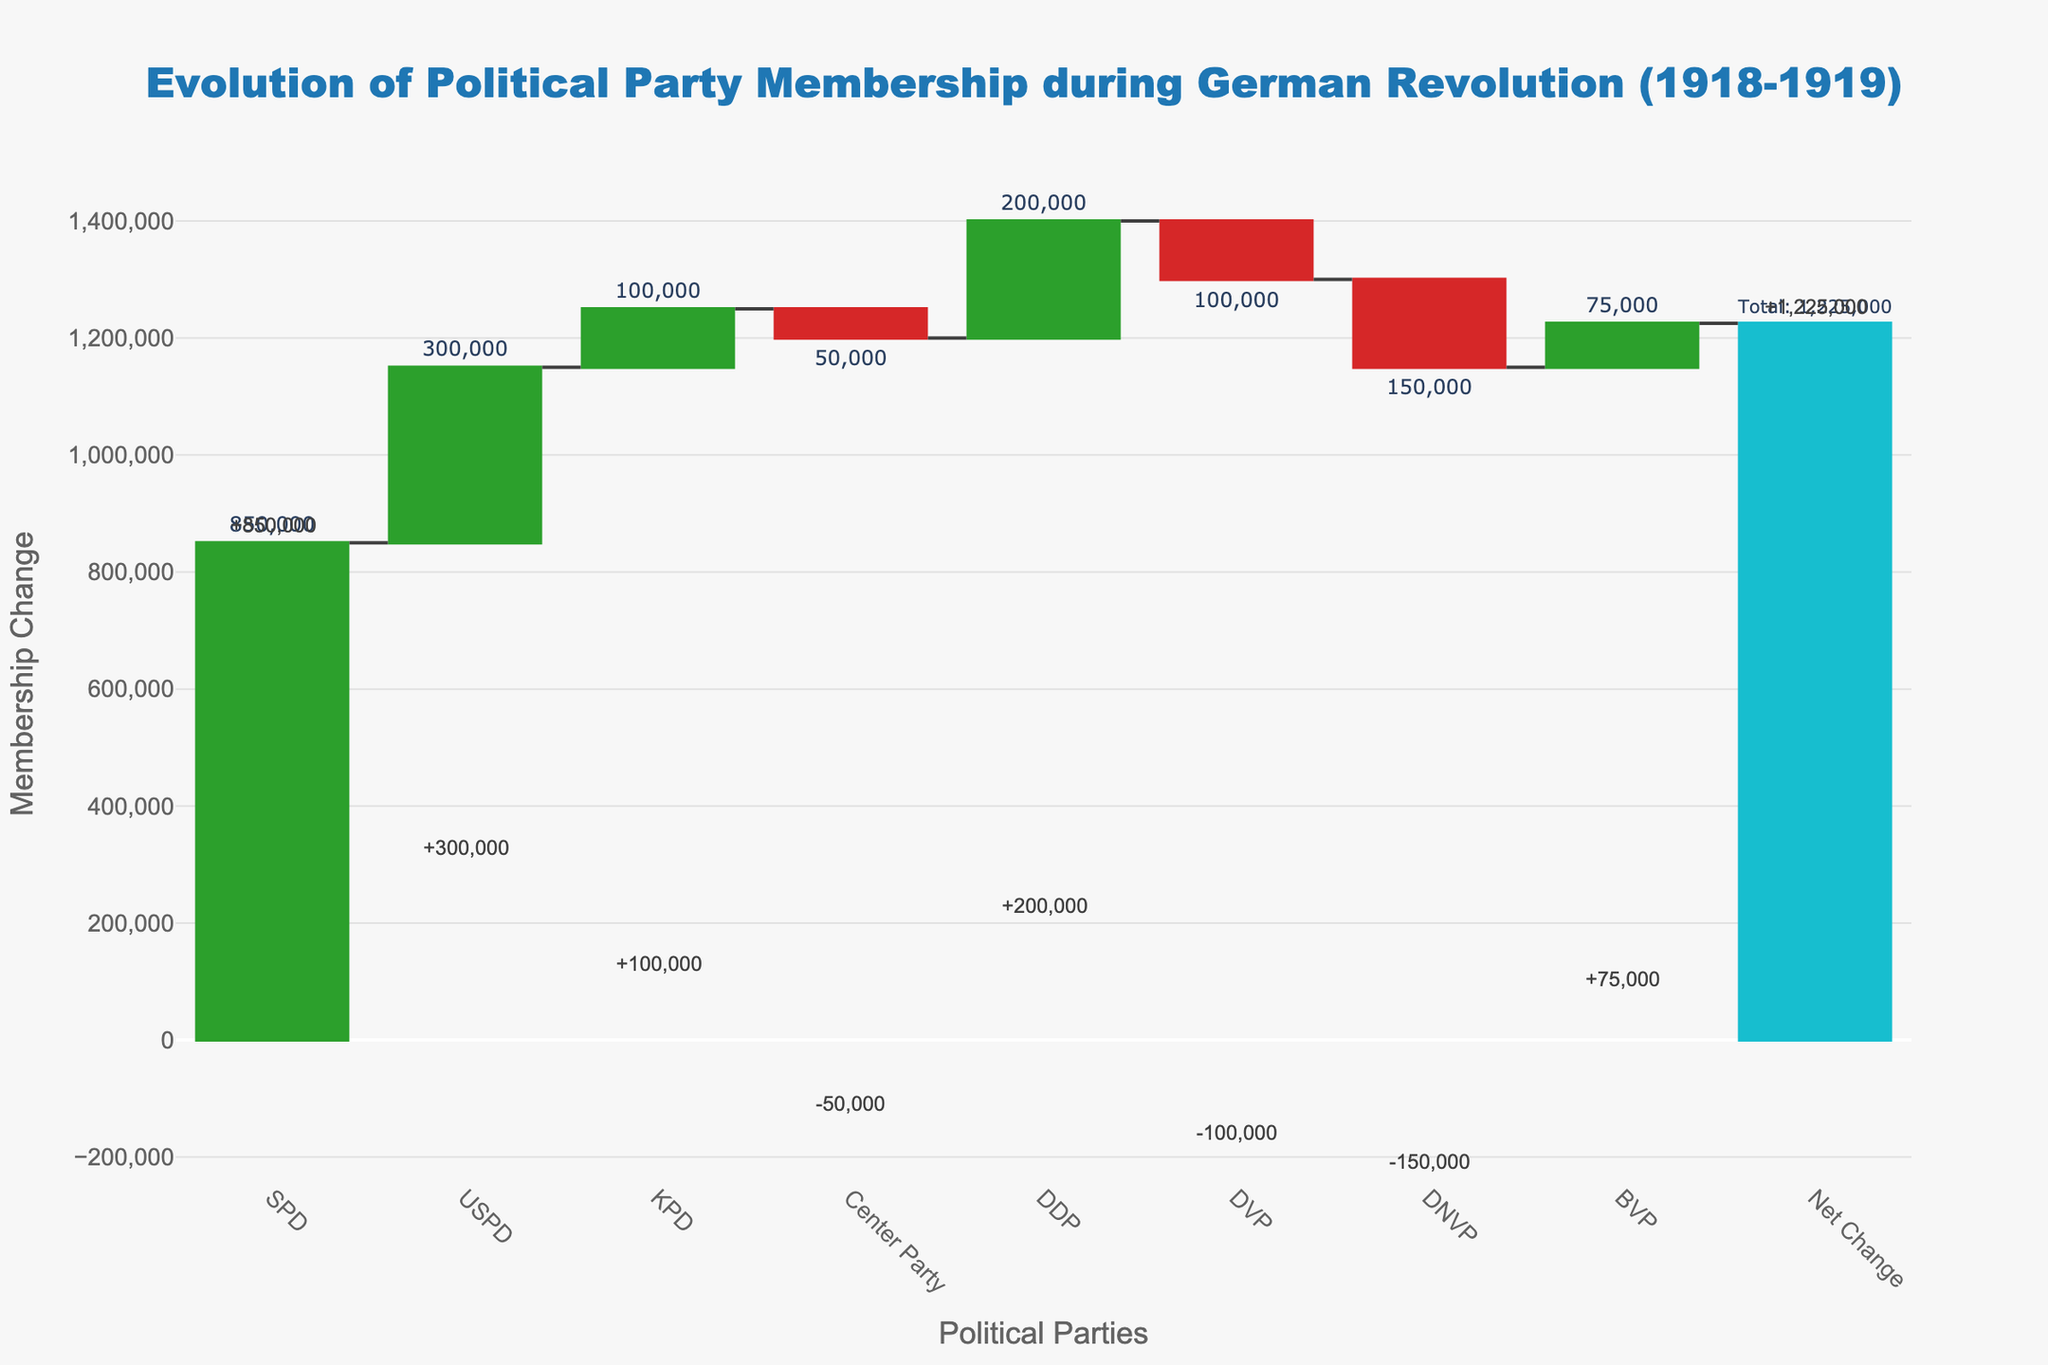How many political parties are shown in the chart? The x-axis displays the categories representing each political party. Counting these categories will give us the number of political parties shown.
Answer: 8 Which political party experienced the highest increase in membership? The green bars in the chart represent increasing membership values. Identifying the tallest green bar (SPD) will indicate the party with the highest increase.
Answer: SPD What is the total net change in political party memberships? The chart includes a final bar labeled "Net Change" that shows the total change in membership across all parties.
Answer: 1,225,000 Which party lost the most members, and how many did they lose? The red bars signify decreasing membership values. Comparing the heights of the red bars shows that DNVP lost the most members.
Answer: DNVP, 150000 What is the total membership change for left-wing parties (SPD, USPD, KPD)? Summing the changes for SPD (+850,000), USPD (+300,000), and KPD (+100,000) will give the total change for left-wing parties.
Answer: 1,250,000 Which party had a minor change compared to others, and what was the magnitude of the change? By comparing the size of the bars, BVP is identified with a relatively minor change. The change magnitude was +75,000.
Answer: BVP, 75000 How does the membership change for DDP compare to that for DVP? The green bar for DDP shows an increase of 200,000, while the red bar for DVP shows a decrease of 100,000. The difference can be calculated by summing the absolute values of their changes (200,000 + 100,000).
Answer: DDP had a greater net change with +200,000 compared to DVP's -100,000 How much larger is SPD’s membership increase compared to the Center Party’s membership decrease? SPD’s membership increase is +850,000, while the Center Party’s decrease is -50,000. Subtracting the absolute values (850,000 - 50,000) gives the difference.
Answer: 800,000 What is the net change in membership for center-right parties (DDP, DVP, DNVP, Center Party)? Adding the membership changes for DDP (+200,000), DVP (-100,000), DNVP (-150,000), and Center Party (-50,000) will provide the net change.
Answer: -100,000 